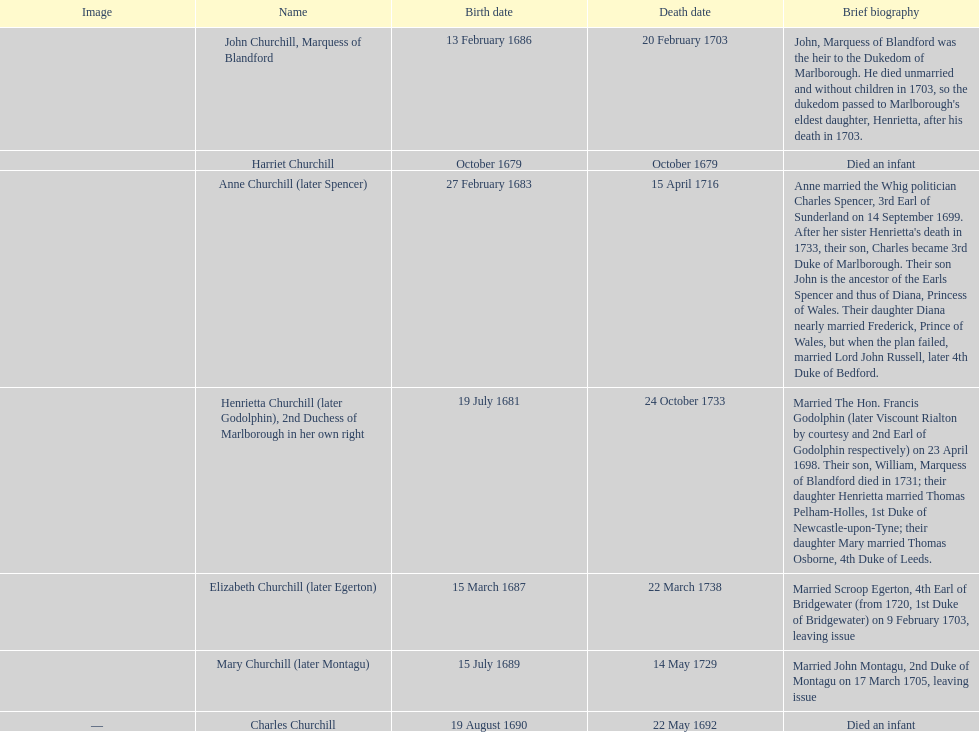How many children were born in february? 2. 